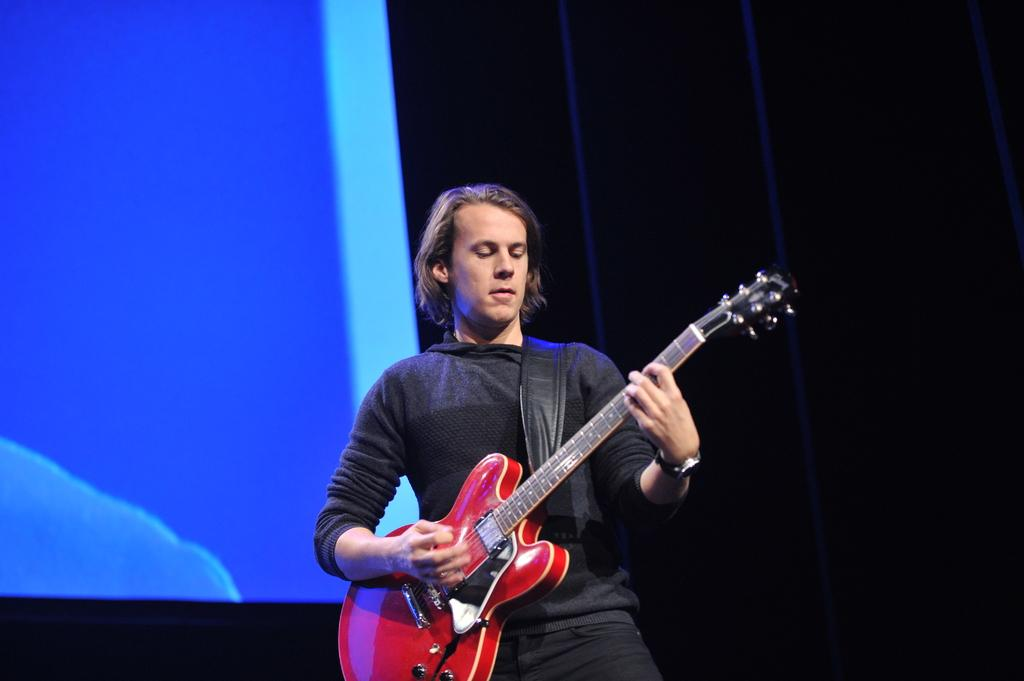Who is present in the image? There is a man in the image. What is the man holding in the image? The man is holding a red color guitar. What type of nose can be seen on the playground in the image? There is no playground or nose present in the image; it features a man holding a red color guitar. 